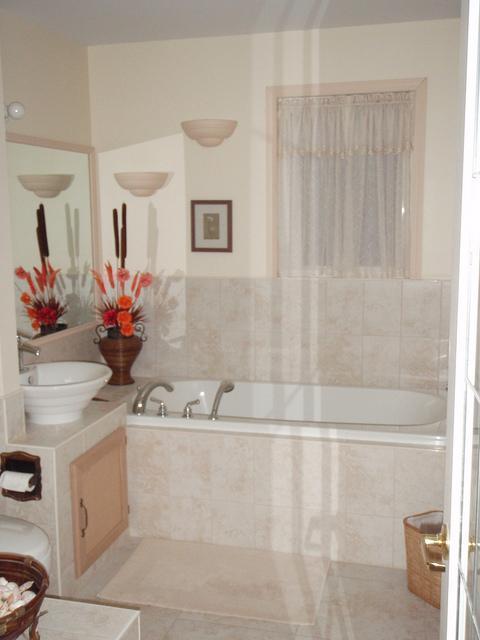How many sinks can be seen?
Give a very brief answer. 1. How many people are typing computer?
Give a very brief answer. 0. 